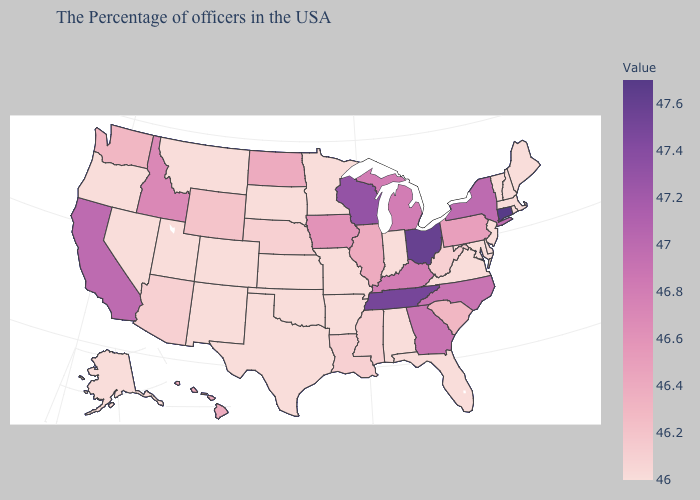Does Connecticut have the highest value in the USA?
Short answer required. Yes. Which states have the lowest value in the West?
Short answer required. Colorado, New Mexico, Utah, Montana, Nevada, Oregon, Alaska. Which states have the lowest value in the USA?
Keep it brief. Maine, Massachusetts, Rhode Island, New Hampshire, Vermont, New Jersey, Delaware, Maryland, Virginia, Florida, Indiana, Alabama, Missouri, Arkansas, Minnesota, Kansas, Oklahoma, Texas, South Dakota, Colorado, New Mexico, Utah, Montana, Nevada, Oregon, Alaska. Does Connecticut have the highest value in the USA?
Quick response, please. Yes. 